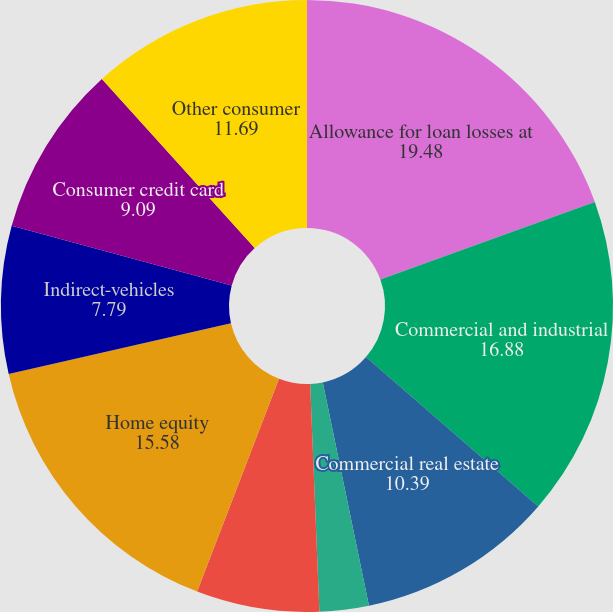Convert chart. <chart><loc_0><loc_0><loc_500><loc_500><pie_chart><fcel>Allowance for loan losses at<fcel>Commercial and industrial<fcel>Commercial real estate<fcel>Commercial investor real<fcel>Residential first mortgage<fcel>Home equity<fcel>Indirect-vehicles<fcel>Consumer credit card<fcel>Other consumer<nl><fcel>19.48%<fcel>16.88%<fcel>10.39%<fcel>2.6%<fcel>6.49%<fcel>15.58%<fcel>7.79%<fcel>9.09%<fcel>11.69%<nl></chart> 